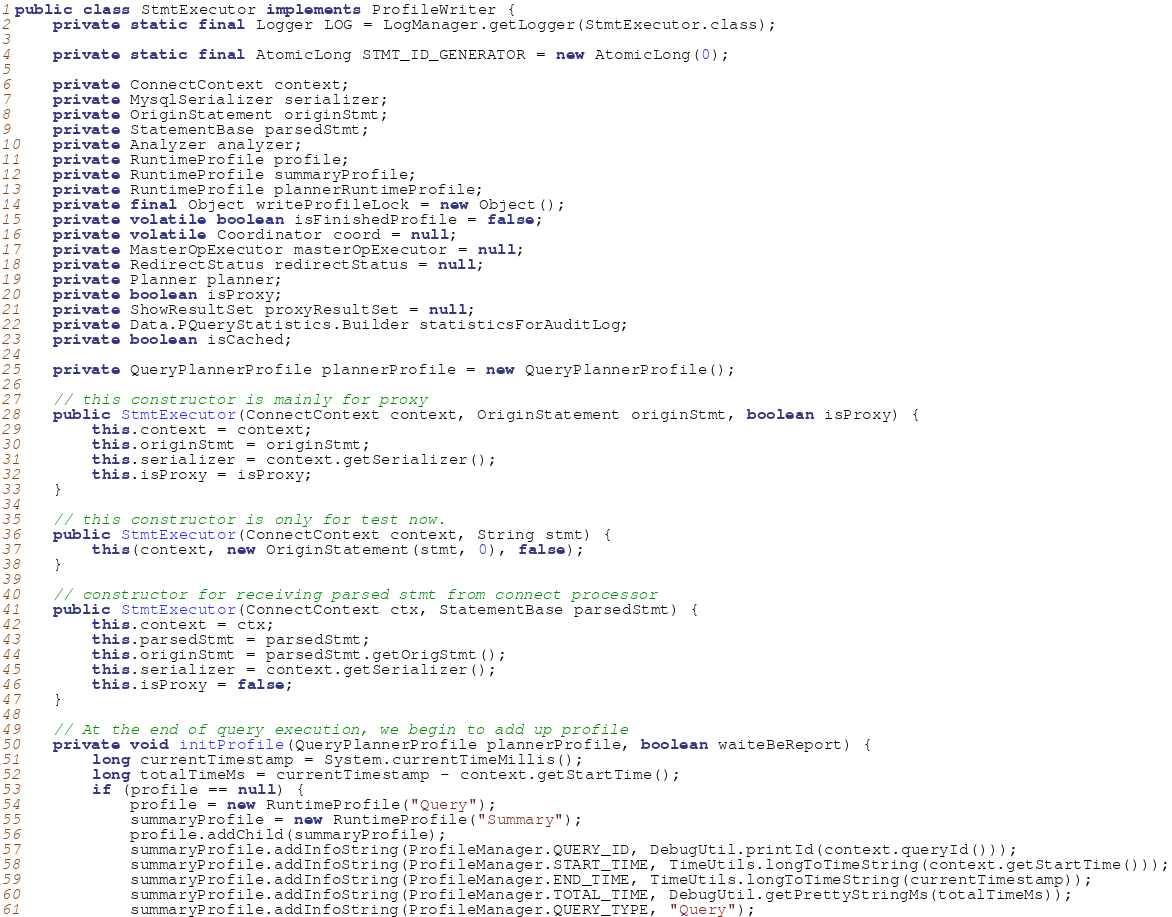<code> <loc_0><loc_0><loc_500><loc_500><_Java_>public class StmtExecutor implements ProfileWriter {
    private static final Logger LOG = LogManager.getLogger(StmtExecutor.class);

    private static final AtomicLong STMT_ID_GENERATOR = new AtomicLong(0);

    private ConnectContext context;
    private MysqlSerializer serializer;
    private OriginStatement originStmt;
    private StatementBase parsedStmt;
    private Analyzer analyzer;
    private RuntimeProfile profile;
    private RuntimeProfile summaryProfile;
    private RuntimeProfile plannerRuntimeProfile;
    private final Object writeProfileLock = new Object();
    private volatile boolean isFinishedProfile = false;
    private volatile Coordinator coord = null;
    private MasterOpExecutor masterOpExecutor = null;
    private RedirectStatus redirectStatus = null;
    private Planner planner;
    private boolean isProxy;
    private ShowResultSet proxyResultSet = null;
    private Data.PQueryStatistics.Builder statisticsForAuditLog;
    private boolean isCached;

    private QueryPlannerProfile plannerProfile = new QueryPlannerProfile();

    // this constructor is mainly for proxy
    public StmtExecutor(ConnectContext context, OriginStatement originStmt, boolean isProxy) {
        this.context = context;
        this.originStmt = originStmt;
        this.serializer = context.getSerializer();
        this.isProxy = isProxy;
    }

    // this constructor is only for test now.
    public StmtExecutor(ConnectContext context, String stmt) {
        this(context, new OriginStatement(stmt, 0), false);
    }

    // constructor for receiving parsed stmt from connect processor
    public StmtExecutor(ConnectContext ctx, StatementBase parsedStmt) {
        this.context = ctx;
        this.parsedStmt = parsedStmt;
        this.originStmt = parsedStmt.getOrigStmt();
        this.serializer = context.getSerializer();
        this.isProxy = false;
    }

    // At the end of query execution, we begin to add up profile
    private void initProfile(QueryPlannerProfile plannerProfile, boolean waiteBeReport) {
        long currentTimestamp = System.currentTimeMillis();
        long totalTimeMs = currentTimestamp - context.getStartTime();
        if (profile == null) {
            profile = new RuntimeProfile("Query");
            summaryProfile = new RuntimeProfile("Summary");
            profile.addChild(summaryProfile);
            summaryProfile.addInfoString(ProfileManager.QUERY_ID, DebugUtil.printId(context.queryId()));
            summaryProfile.addInfoString(ProfileManager.START_TIME, TimeUtils.longToTimeString(context.getStartTime()));
            summaryProfile.addInfoString(ProfileManager.END_TIME, TimeUtils.longToTimeString(currentTimestamp));
            summaryProfile.addInfoString(ProfileManager.TOTAL_TIME, DebugUtil.getPrettyStringMs(totalTimeMs));
            summaryProfile.addInfoString(ProfileManager.QUERY_TYPE, "Query");</code> 